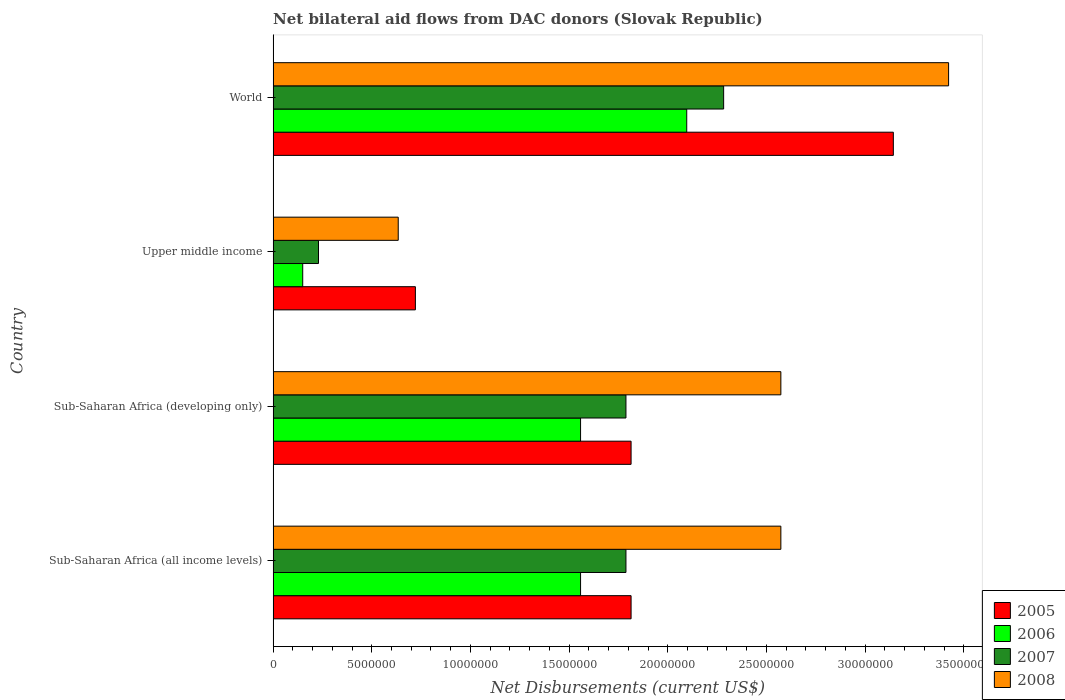How many different coloured bars are there?
Provide a succinct answer. 4. How many groups of bars are there?
Make the answer very short. 4. How many bars are there on the 2nd tick from the top?
Keep it short and to the point. 4. What is the label of the 4th group of bars from the top?
Make the answer very short. Sub-Saharan Africa (all income levels). In how many cases, is the number of bars for a given country not equal to the number of legend labels?
Offer a terse response. 0. What is the net bilateral aid flows in 2005 in World?
Your answer should be compact. 3.14e+07. Across all countries, what is the maximum net bilateral aid flows in 2005?
Make the answer very short. 3.14e+07. Across all countries, what is the minimum net bilateral aid flows in 2005?
Your response must be concise. 7.21e+06. In which country was the net bilateral aid flows in 2008 minimum?
Keep it short and to the point. Upper middle income. What is the total net bilateral aid flows in 2006 in the graph?
Provide a short and direct response. 5.36e+07. What is the difference between the net bilateral aid flows in 2006 in Sub-Saharan Africa (all income levels) and that in Sub-Saharan Africa (developing only)?
Make the answer very short. 0. What is the difference between the net bilateral aid flows in 2008 in Sub-Saharan Africa (all income levels) and the net bilateral aid flows in 2007 in World?
Your answer should be very brief. 2.90e+06. What is the average net bilateral aid flows in 2005 per country?
Your answer should be compact. 1.87e+07. What is the difference between the net bilateral aid flows in 2007 and net bilateral aid flows in 2008 in World?
Offer a terse response. -1.14e+07. What is the ratio of the net bilateral aid flows in 2008 in Sub-Saharan Africa (developing only) to that in Upper middle income?
Your response must be concise. 4.06. Is the net bilateral aid flows in 2005 in Sub-Saharan Africa (all income levels) less than that in World?
Provide a short and direct response. Yes. What is the difference between the highest and the second highest net bilateral aid flows in 2006?
Provide a short and direct response. 5.38e+06. What is the difference between the highest and the lowest net bilateral aid flows in 2006?
Provide a short and direct response. 1.95e+07. In how many countries, is the net bilateral aid flows in 2007 greater than the average net bilateral aid flows in 2007 taken over all countries?
Offer a very short reply. 3. Is the sum of the net bilateral aid flows in 2006 in Sub-Saharan Africa (all income levels) and Sub-Saharan Africa (developing only) greater than the maximum net bilateral aid flows in 2008 across all countries?
Offer a very short reply. No. Is it the case that in every country, the sum of the net bilateral aid flows in 2006 and net bilateral aid flows in 2007 is greater than the sum of net bilateral aid flows in 2005 and net bilateral aid flows in 2008?
Your answer should be compact. No. What does the 4th bar from the top in Sub-Saharan Africa (developing only) represents?
Provide a short and direct response. 2005. How many bars are there?
Offer a terse response. 16. Are all the bars in the graph horizontal?
Provide a succinct answer. Yes. What is the difference between two consecutive major ticks on the X-axis?
Your answer should be compact. 5.00e+06. Does the graph contain grids?
Provide a short and direct response. No. Where does the legend appear in the graph?
Your response must be concise. Bottom right. What is the title of the graph?
Your answer should be compact. Net bilateral aid flows from DAC donors (Slovak Republic). What is the label or title of the X-axis?
Offer a terse response. Net Disbursements (current US$). What is the Net Disbursements (current US$) in 2005 in Sub-Saharan Africa (all income levels)?
Offer a terse response. 1.81e+07. What is the Net Disbursements (current US$) of 2006 in Sub-Saharan Africa (all income levels)?
Offer a terse response. 1.56e+07. What is the Net Disbursements (current US$) in 2007 in Sub-Saharan Africa (all income levels)?
Ensure brevity in your answer.  1.79e+07. What is the Net Disbursements (current US$) in 2008 in Sub-Saharan Africa (all income levels)?
Give a very brief answer. 2.57e+07. What is the Net Disbursements (current US$) in 2005 in Sub-Saharan Africa (developing only)?
Offer a terse response. 1.81e+07. What is the Net Disbursements (current US$) of 2006 in Sub-Saharan Africa (developing only)?
Provide a succinct answer. 1.56e+07. What is the Net Disbursements (current US$) in 2007 in Sub-Saharan Africa (developing only)?
Offer a very short reply. 1.79e+07. What is the Net Disbursements (current US$) of 2008 in Sub-Saharan Africa (developing only)?
Give a very brief answer. 2.57e+07. What is the Net Disbursements (current US$) in 2005 in Upper middle income?
Your response must be concise. 7.21e+06. What is the Net Disbursements (current US$) of 2006 in Upper middle income?
Your response must be concise. 1.50e+06. What is the Net Disbursements (current US$) of 2007 in Upper middle income?
Provide a short and direct response. 2.30e+06. What is the Net Disbursements (current US$) of 2008 in Upper middle income?
Give a very brief answer. 6.34e+06. What is the Net Disbursements (current US$) in 2005 in World?
Your answer should be very brief. 3.14e+07. What is the Net Disbursements (current US$) of 2006 in World?
Provide a succinct answer. 2.10e+07. What is the Net Disbursements (current US$) of 2007 in World?
Provide a short and direct response. 2.28e+07. What is the Net Disbursements (current US$) of 2008 in World?
Give a very brief answer. 3.42e+07. Across all countries, what is the maximum Net Disbursements (current US$) in 2005?
Give a very brief answer. 3.14e+07. Across all countries, what is the maximum Net Disbursements (current US$) in 2006?
Your response must be concise. 2.10e+07. Across all countries, what is the maximum Net Disbursements (current US$) of 2007?
Your response must be concise. 2.28e+07. Across all countries, what is the maximum Net Disbursements (current US$) in 2008?
Give a very brief answer. 3.42e+07. Across all countries, what is the minimum Net Disbursements (current US$) of 2005?
Give a very brief answer. 7.21e+06. Across all countries, what is the minimum Net Disbursements (current US$) of 2006?
Provide a succinct answer. 1.50e+06. Across all countries, what is the minimum Net Disbursements (current US$) of 2007?
Keep it short and to the point. 2.30e+06. Across all countries, what is the minimum Net Disbursements (current US$) of 2008?
Provide a short and direct response. 6.34e+06. What is the total Net Disbursements (current US$) of 2005 in the graph?
Make the answer very short. 7.49e+07. What is the total Net Disbursements (current US$) of 2006 in the graph?
Keep it short and to the point. 5.36e+07. What is the total Net Disbursements (current US$) in 2007 in the graph?
Make the answer very short. 6.09e+07. What is the total Net Disbursements (current US$) of 2008 in the graph?
Ensure brevity in your answer.  9.20e+07. What is the difference between the Net Disbursements (current US$) in 2005 in Sub-Saharan Africa (all income levels) and that in Sub-Saharan Africa (developing only)?
Ensure brevity in your answer.  0. What is the difference between the Net Disbursements (current US$) of 2006 in Sub-Saharan Africa (all income levels) and that in Sub-Saharan Africa (developing only)?
Offer a terse response. 0. What is the difference between the Net Disbursements (current US$) in 2005 in Sub-Saharan Africa (all income levels) and that in Upper middle income?
Provide a short and direct response. 1.09e+07. What is the difference between the Net Disbursements (current US$) of 2006 in Sub-Saharan Africa (all income levels) and that in Upper middle income?
Make the answer very short. 1.41e+07. What is the difference between the Net Disbursements (current US$) in 2007 in Sub-Saharan Africa (all income levels) and that in Upper middle income?
Keep it short and to the point. 1.56e+07. What is the difference between the Net Disbursements (current US$) in 2008 in Sub-Saharan Africa (all income levels) and that in Upper middle income?
Offer a terse response. 1.94e+07. What is the difference between the Net Disbursements (current US$) in 2005 in Sub-Saharan Africa (all income levels) and that in World?
Give a very brief answer. -1.33e+07. What is the difference between the Net Disbursements (current US$) of 2006 in Sub-Saharan Africa (all income levels) and that in World?
Offer a very short reply. -5.38e+06. What is the difference between the Net Disbursements (current US$) of 2007 in Sub-Saharan Africa (all income levels) and that in World?
Provide a short and direct response. -4.95e+06. What is the difference between the Net Disbursements (current US$) in 2008 in Sub-Saharan Africa (all income levels) and that in World?
Make the answer very short. -8.50e+06. What is the difference between the Net Disbursements (current US$) in 2005 in Sub-Saharan Africa (developing only) and that in Upper middle income?
Offer a very short reply. 1.09e+07. What is the difference between the Net Disbursements (current US$) in 2006 in Sub-Saharan Africa (developing only) and that in Upper middle income?
Your answer should be compact. 1.41e+07. What is the difference between the Net Disbursements (current US$) of 2007 in Sub-Saharan Africa (developing only) and that in Upper middle income?
Your response must be concise. 1.56e+07. What is the difference between the Net Disbursements (current US$) of 2008 in Sub-Saharan Africa (developing only) and that in Upper middle income?
Offer a very short reply. 1.94e+07. What is the difference between the Net Disbursements (current US$) in 2005 in Sub-Saharan Africa (developing only) and that in World?
Your answer should be very brief. -1.33e+07. What is the difference between the Net Disbursements (current US$) of 2006 in Sub-Saharan Africa (developing only) and that in World?
Ensure brevity in your answer.  -5.38e+06. What is the difference between the Net Disbursements (current US$) of 2007 in Sub-Saharan Africa (developing only) and that in World?
Provide a succinct answer. -4.95e+06. What is the difference between the Net Disbursements (current US$) in 2008 in Sub-Saharan Africa (developing only) and that in World?
Provide a succinct answer. -8.50e+06. What is the difference between the Net Disbursements (current US$) in 2005 in Upper middle income and that in World?
Your answer should be compact. -2.42e+07. What is the difference between the Net Disbursements (current US$) in 2006 in Upper middle income and that in World?
Ensure brevity in your answer.  -1.95e+07. What is the difference between the Net Disbursements (current US$) in 2007 in Upper middle income and that in World?
Make the answer very short. -2.05e+07. What is the difference between the Net Disbursements (current US$) in 2008 in Upper middle income and that in World?
Provide a short and direct response. -2.79e+07. What is the difference between the Net Disbursements (current US$) in 2005 in Sub-Saharan Africa (all income levels) and the Net Disbursements (current US$) in 2006 in Sub-Saharan Africa (developing only)?
Your response must be concise. 2.56e+06. What is the difference between the Net Disbursements (current US$) in 2005 in Sub-Saharan Africa (all income levels) and the Net Disbursements (current US$) in 2007 in Sub-Saharan Africa (developing only)?
Your answer should be compact. 2.60e+05. What is the difference between the Net Disbursements (current US$) of 2005 in Sub-Saharan Africa (all income levels) and the Net Disbursements (current US$) of 2008 in Sub-Saharan Africa (developing only)?
Provide a short and direct response. -7.59e+06. What is the difference between the Net Disbursements (current US$) in 2006 in Sub-Saharan Africa (all income levels) and the Net Disbursements (current US$) in 2007 in Sub-Saharan Africa (developing only)?
Make the answer very short. -2.30e+06. What is the difference between the Net Disbursements (current US$) in 2006 in Sub-Saharan Africa (all income levels) and the Net Disbursements (current US$) in 2008 in Sub-Saharan Africa (developing only)?
Your answer should be very brief. -1.02e+07. What is the difference between the Net Disbursements (current US$) of 2007 in Sub-Saharan Africa (all income levels) and the Net Disbursements (current US$) of 2008 in Sub-Saharan Africa (developing only)?
Provide a short and direct response. -7.85e+06. What is the difference between the Net Disbursements (current US$) of 2005 in Sub-Saharan Africa (all income levels) and the Net Disbursements (current US$) of 2006 in Upper middle income?
Give a very brief answer. 1.66e+07. What is the difference between the Net Disbursements (current US$) of 2005 in Sub-Saharan Africa (all income levels) and the Net Disbursements (current US$) of 2007 in Upper middle income?
Keep it short and to the point. 1.58e+07. What is the difference between the Net Disbursements (current US$) in 2005 in Sub-Saharan Africa (all income levels) and the Net Disbursements (current US$) in 2008 in Upper middle income?
Ensure brevity in your answer.  1.18e+07. What is the difference between the Net Disbursements (current US$) in 2006 in Sub-Saharan Africa (all income levels) and the Net Disbursements (current US$) in 2007 in Upper middle income?
Your answer should be very brief. 1.33e+07. What is the difference between the Net Disbursements (current US$) of 2006 in Sub-Saharan Africa (all income levels) and the Net Disbursements (current US$) of 2008 in Upper middle income?
Offer a very short reply. 9.24e+06. What is the difference between the Net Disbursements (current US$) of 2007 in Sub-Saharan Africa (all income levels) and the Net Disbursements (current US$) of 2008 in Upper middle income?
Make the answer very short. 1.15e+07. What is the difference between the Net Disbursements (current US$) of 2005 in Sub-Saharan Africa (all income levels) and the Net Disbursements (current US$) of 2006 in World?
Your response must be concise. -2.82e+06. What is the difference between the Net Disbursements (current US$) in 2005 in Sub-Saharan Africa (all income levels) and the Net Disbursements (current US$) in 2007 in World?
Your response must be concise. -4.69e+06. What is the difference between the Net Disbursements (current US$) in 2005 in Sub-Saharan Africa (all income levels) and the Net Disbursements (current US$) in 2008 in World?
Your answer should be very brief. -1.61e+07. What is the difference between the Net Disbursements (current US$) in 2006 in Sub-Saharan Africa (all income levels) and the Net Disbursements (current US$) in 2007 in World?
Your answer should be very brief. -7.25e+06. What is the difference between the Net Disbursements (current US$) in 2006 in Sub-Saharan Africa (all income levels) and the Net Disbursements (current US$) in 2008 in World?
Provide a succinct answer. -1.86e+07. What is the difference between the Net Disbursements (current US$) of 2007 in Sub-Saharan Africa (all income levels) and the Net Disbursements (current US$) of 2008 in World?
Offer a terse response. -1.64e+07. What is the difference between the Net Disbursements (current US$) in 2005 in Sub-Saharan Africa (developing only) and the Net Disbursements (current US$) in 2006 in Upper middle income?
Keep it short and to the point. 1.66e+07. What is the difference between the Net Disbursements (current US$) in 2005 in Sub-Saharan Africa (developing only) and the Net Disbursements (current US$) in 2007 in Upper middle income?
Make the answer very short. 1.58e+07. What is the difference between the Net Disbursements (current US$) of 2005 in Sub-Saharan Africa (developing only) and the Net Disbursements (current US$) of 2008 in Upper middle income?
Provide a short and direct response. 1.18e+07. What is the difference between the Net Disbursements (current US$) in 2006 in Sub-Saharan Africa (developing only) and the Net Disbursements (current US$) in 2007 in Upper middle income?
Make the answer very short. 1.33e+07. What is the difference between the Net Disbursements (current US$) of 2006 in Sub-Saharan Africa (developing only) and the Net Disbursements (current US$) of 2008 in Upper middle income?
Your response must be concise. 9.24e+06. What is the difference between the Net Disbursements (current US$) in 2007 in Sub-Saharan Africa (developing only) and the Net Disbursements (current US$) in 2008 in Upper middle income?
Provide a short and direct response. 1.15e+07. What is the difference between the Net Disbursements (current US$) in 2005 in Sub-Saharan Africa (developing only) and the Net Disbursements (current US$) in 2006 in World?
Ensure brevity in your answer.  -2.82e+06. What is the difference between the Net Disbursements (current US$) of 2005 in Sub-Saharan Africa (developing only) and the Net Disbursements (current US$) of 2007 in World?
Offer a very short reply. -4.69e+06. What is the difference between the Net Disbursements (current US$) of 2005 in Sub-Saharan Africa (developing only) and the Net Disbursements (current US$) of 2008 in World?
Your answer should be very brief. -1.61e+07. What is the difference between the Net Disbursements (current US$) in 2006 in Sub-Saharan Africa (developing only) and the Net Disbursements (current US$) in 2007 in World?
Make the answer very short. -7.25e+06. What is the difference between the Net Disbursements (current US$) of 2006 in Sub-Saharan Africa (developing only) and the Net Disbursements (current US$) of 2008 in World?
Offer a very short reply. -1.86e+07. What is the difference between the Net Disbursements (current US$) in 2007 in Sub-Saharan Africa (developing only) and the Net Disbursements (current US$) in 2008 in World?
Your answer should be very brief. -1.64e+07. What is the difference between the Net Disbursements (current US$) in 2005 in Upper middle income and the Net Disbursements (current US$) in 2006 in World?
Provide a short and direct response. -1.38e+07. What is the difference between the Net Disbursements (current US$) in 2005 in Upper middle income and the Net Disbursements (current US$) in 2007 in World?
Your response must be concise. -1.56e+07. What is the difference between the Net Disbursements (current US$) of 2005 in Upper middle income and the Net Disbursements (current US$) of 2008 in World?
Ensure brevity in your answer.  -2.70e+07. What is the difference between the Net Disbursements (current US$) of 2006 in Upper middle income and the Net Disbursements (current US$) of 2007 in World?
Your response must be concise. -2.13e+07. What is the difference between the Net Disbursements (current US$) in 2006 in Upper middle income and the Net Disbursements (current US$) in 2008 in World?
Provide a short and direct response. -3.27e+07. What is the difference between the Net Disbursements (current US$) in 2007 in Upper middle income and the Net Disbursements (current US$) in 2008 in World?
Your answer should be very brief. -3.19e+07. What is the average Net Disbursements (current US$) in 2005 per country?
Keep it short and to the point. 1.87e+07. What is the average Net Disbursements (current US$) of 2006 per country?
Offer a very short reply. 1.34e+07. What is the average Net Disbursements (current US$) of 2007 per country?
Offer a terse response. 1.52e+07. What is the average Net Disbursements (current US$) of 2008 per country?
Ensure brevity in your answer.  2.30e+07. What is the difference between the Net Disbursements (current US$) in 2005 and Net Disbursements (current US$) in 2006 in Sub-Saharan Africa (all income levels)?
Provide a short and direct response. 2.56e+06. What is the difference between the Net Disbursements (current US$) of 2005 and Net Disbursements (current US$) of 2007 in Sub-Saharan Africa (all income levels)?
Keep it short and to the point. 2.60e+05. What is the difference between the Net Disbursements (current US$) in 2005 and Net Disbursements (current US$) in 2008 in Sub-Saharan Africa (all income levels)?
Offer a terse response. -7.59e+06. What is the difference between the Net Disbursements (current US$) in 2006 and Net Disbursements (current US$) in 2007 in Sub-Saharan Africa (all income levels)?
Ensure brevity in your answer.  -2.30e+06. What is the difference between the Net Disbursements (current US$) of 2006 and Net Disbursements (current US$) of 2008 in Sub-Saharan Africa (all income levels)?
Provide a short and direct response. -1.02e+07. What is the difference between the Net Disbursements (current US$) of 2007 and Net Disbursements (current US$) of 2008 in Sub-Saharan Africa (all income levels)?
Provide a succinct answer. -7.85e+06. What is the difference between the Net Disbursements (current US$) in 2005 and Net Disbursements (current US$) in 2006 in Sub-Saharan Africa (developing only)?
Your answer should be compact. 2.56e+06. What is the difference between the Net Disbursements (current US$) of 2005 and Net Disbursements (current US$) of 2007 in Sub-Saharan Africa (developing only)?
Your answer should be compact. 2.60e+05. What is the difference between the Net Disbursements (current US$) in 2005 and Net Disbursements (current US$) in 2008 in Sub-Saharan Africa (developing only)?
Provide a succinct answer. -7.59e+06. What is the difference between the Net Disbursements (current US$) of 2006 and Net Disbursements (current US$) of 2007 in Sub-Saharan Africa (developing only)?
Make the answer very short. -2.30e+06. What is the difference between the Net Disbursements (current US$) of 2006 and Net Disbursements (current US$) of 2008 in Sub-Saharan Africa (developing only)?
Your response must be concise. -1.02e+07. What is the difference between the Net Disbursements (current US$) in 2007 and Net Disbursements (current US$) in 2008 in Sub-Saharan Africa (developing only)?
Provide a succinct answer. -7.85e+06. What is the difference between the Net Disbursements (current US$) of 2005 and Net Disbursements (current US$) of 2006 in Upper middle income?
Make the answer very short. 5.71e+06. What is the difference between the Net Disbursements (current US$) in 2005 and Net Disbursements (current US$) in 2007 in Upper middle income?
Provide a short and direct response. 4.91e+06. What is the difference between the Net Disbursements (current US$) of 2005 and Net Disbursements (current US$) of 2008 in Upper middle income?
Make the answer very short. 8.70e+05. What is the difference between the Net Disbursements (current US$) of 2006 and Net Disbursements (current US$) of 2007 in Upper middle income?
Your response must be concise. -8.00e+05. What is the difference between the Net Disbursements (current US$) in 2006 and Net Disbursements (current US$) in 2008 in Upper middle income?
Make the answer very short. -4.84e+06. What is the difference between the Net Disbursements (current US$) in 2007 and Net Disbursements (current US$) in 2008 in Upper middle income?
Offer a terse response. -4.04e+06. What is the difference between the Net Disbursements (current US$) of 2005 and Net Disbursements (current US$) of 2006 in World?
Provide a short and direct response. 1.05e+07. What is the difference between the Net Disbursements (current US$) in 2005 and Net Disbursements (current US$) in 2007 in World?
Offer a very short reply. 8.60e+06. What is the difference between the Net Disbursements (current US$) of 2005 and Net Disbursements (current US$) of 2008 in World?
Provide a short and direct response. -2.80e+06. What is the difference between the Net Disbursements (current US$) in 2006 and Net Disbursements (current US$) in 2007 in World?
Offer a terse response. -1.87e+06. What is the difference between the Net Disbursements (current US$) in 2006 and Net Disbursements (current US$) in 2008 in World?
Provide a short and direct response. -1.33e+07. What is the difference between the Net Disbursements (current US$) in 2007 and Net Disbursements (current US$) in 2008 in World?
Offer a terse response. -1.14e+07. What is the ratio of the Net Disbursements (current US$) in 2005 in Sub-Saharan Africa (all income levels) to that in Sub-Saharan Africa (developing only)?
Your answer should be compact. 1. What is the ratio of the Net Disbursements (current US$) of 2007 in Sub-Saharan Africa (all income levels) to that in Sub-Saharan Africa (developing only)?
Provide a succinct answer. 1. What is the ratio of the Net Disbursements (current US$) in 2005 in Sub-Saharan Africa (all income levels) to that in Upper middle income?
Offer a terse response. 2.52. What is the ratio of the Net Disbursements (current US$) in 2006 in Sub-Saharan Africa (all income levels) to that in Upper middle income?
Your answer should be very brief. 10.39. What is the ratio of the Net Disbursements (current US$) in 2007 in Sub-Saharan Africa (all income levels) to that in Upper middle income?
Your response must be concise. 7.77. What is the ratio of the Net Disbursements (current US$) in 2008 in Sub-Saharan Africa (all income levels) to that in Upper middle income?
Give a very brief answer. 4.06. What is the ratio of the Net Disbursements (current US$) of 2005 in Sub-Saharan Africa (all income levels) to that in World?
Give a very brief answer. 0.58. What is the ratio of the Net Disbursements (current US$) of 2006 in Sub-Saharan Africa (all income levels) to that in World?
Ensure brevity in your answer.  0.74. What is the ratio of the Net Disbursements (current US$) in 2007 in Sub-Saharan Africa (all income levels) to that in World?
Make the answer very short. 0.78. What is the ratio of the Net Disbursements (current US$) in 2008 in Sub-Saharan Africa (all income levels) to that in World?
Give a very brief answer. 0.75. What is the ratio of the Net Disbursements (current US$) in 2005 in Sub-Saharan Africa (developing only) to that in Upper middle income?
Provide a succinct answer. 2.52. What is the ratio of the Net Disbursements (current US$) of 2006 in Sub-Saharan Africa (developing only) to that in Upper middle income?
Provide a short and direct response. 10.39. What is the ratio of the Net Disbursements (current US$) of 2007 in Sub-Saharan Africa (developing only) to that in Upper middle income?
Make the answer very short. 7.77. What is the ratio of the Net Disbursements (current US$) of 2008 in Sub-Saharan Africa (developing only) to that in Upper middle income?
Make the answer very short. 4.06. What is the ratio of the Net Disbursements (current US$) of 2005 in Sub-Saharan Africa (developing only) to that in World?
Your answer should be compact. 0.58. What is the ratio of the Net Disbursements (current US$) of 2006 in Sub-Saharan Africa (developing only) to that in World?
Ensure brevity in your answer.  0.74. What is the ratio of the Net Disbursements (current US$) of 2007 in Sub-Saharan Africa (developing only) to that in World?
Your response must be concise. 0.78. What is the ratio of the Net Disbursements (current US$) of 2008 in Sub-Saharan Africa (developing only) to that in World?
Provide a succinct answer. 0.75. What is the ratio of the Net Disbursements (current US$) of 2005 in Upper middle income to that in World?
Your response must be concise. 0.23. What is the ratio of the Net Disbursements (current US$) of 2006 in Upper middle income to that in World?
Your answer should be very brief. 0.07. What is the ratio of the Net Disbursements (current US$) of 2007 in Upper middle income to that in World?
Your answer should be compact. 0.1. What is the ratio of the Net Disbursements (current US$) in 2008 in Upper middle income to that in World?
Provide a succinct answer. 0.19. What is the difference between the highest and the second highest Net Disbursements (current US$) in 2005?
Provide a succinct answer. 1.33e+07. What is the difference between the highest and the second highest Net Disbursements (current US$) in 2006?
Your answer should be compact. 5.38e+06. What is the difference between the highest and the second highest Net Disbursements (current US$) of 2007?
Your response must be concise. 4.95e+06. What is the difference between the highest and the second highest Net Disbursements (current US$) in 2008?
Make the answer very short. 8.50e+06. What is the difference between the highest and the lowest Net Disbursements (current US$) in 2005?
Give a very brief answer. 2.42e+07. What is the difference between the highest and the lowest Net Disbursements (current US$) of 2006?
Keep it short and to the point. 1.95e+07. What is the difference between the highest and the lowest Net Disbursements (current US$) of 2007?
Offer a very short reply. 2.05e+07. What is the difference between the highest and the lowest Net Disbursements (current US$) of 2008?
Provide a succinct answer. 2.79e+07. 